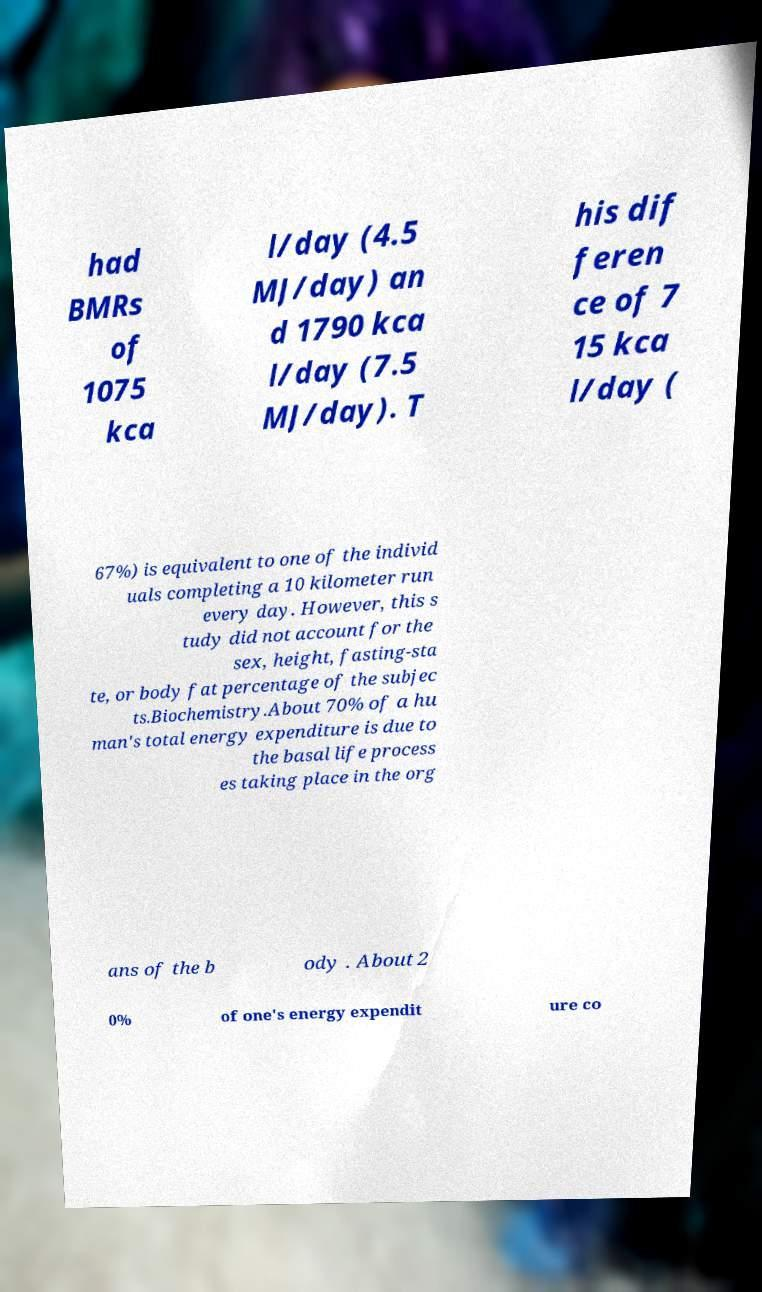What messages or text are displayed in this image? I need them in a readable, typed format. had BMRs of 1075 kca l/day (4.5 MJ/day) an d 1790 kca l/day (7.5 MJ/day). T his dif feren ce of 7 15 kca l/day ( 67%) is equivalent to one of the individ uals completing a 10 kilometer run every day. However, this s tudy did not account for the sex, height, fasting-sta te, or body fat percentage of the subjec ts.Biochemistry.About 70% of a hu man's total energy expenditure is due to the basal life process es taking place in the org ans of the b ody . About 2 0% of one's energy expendit ure co 